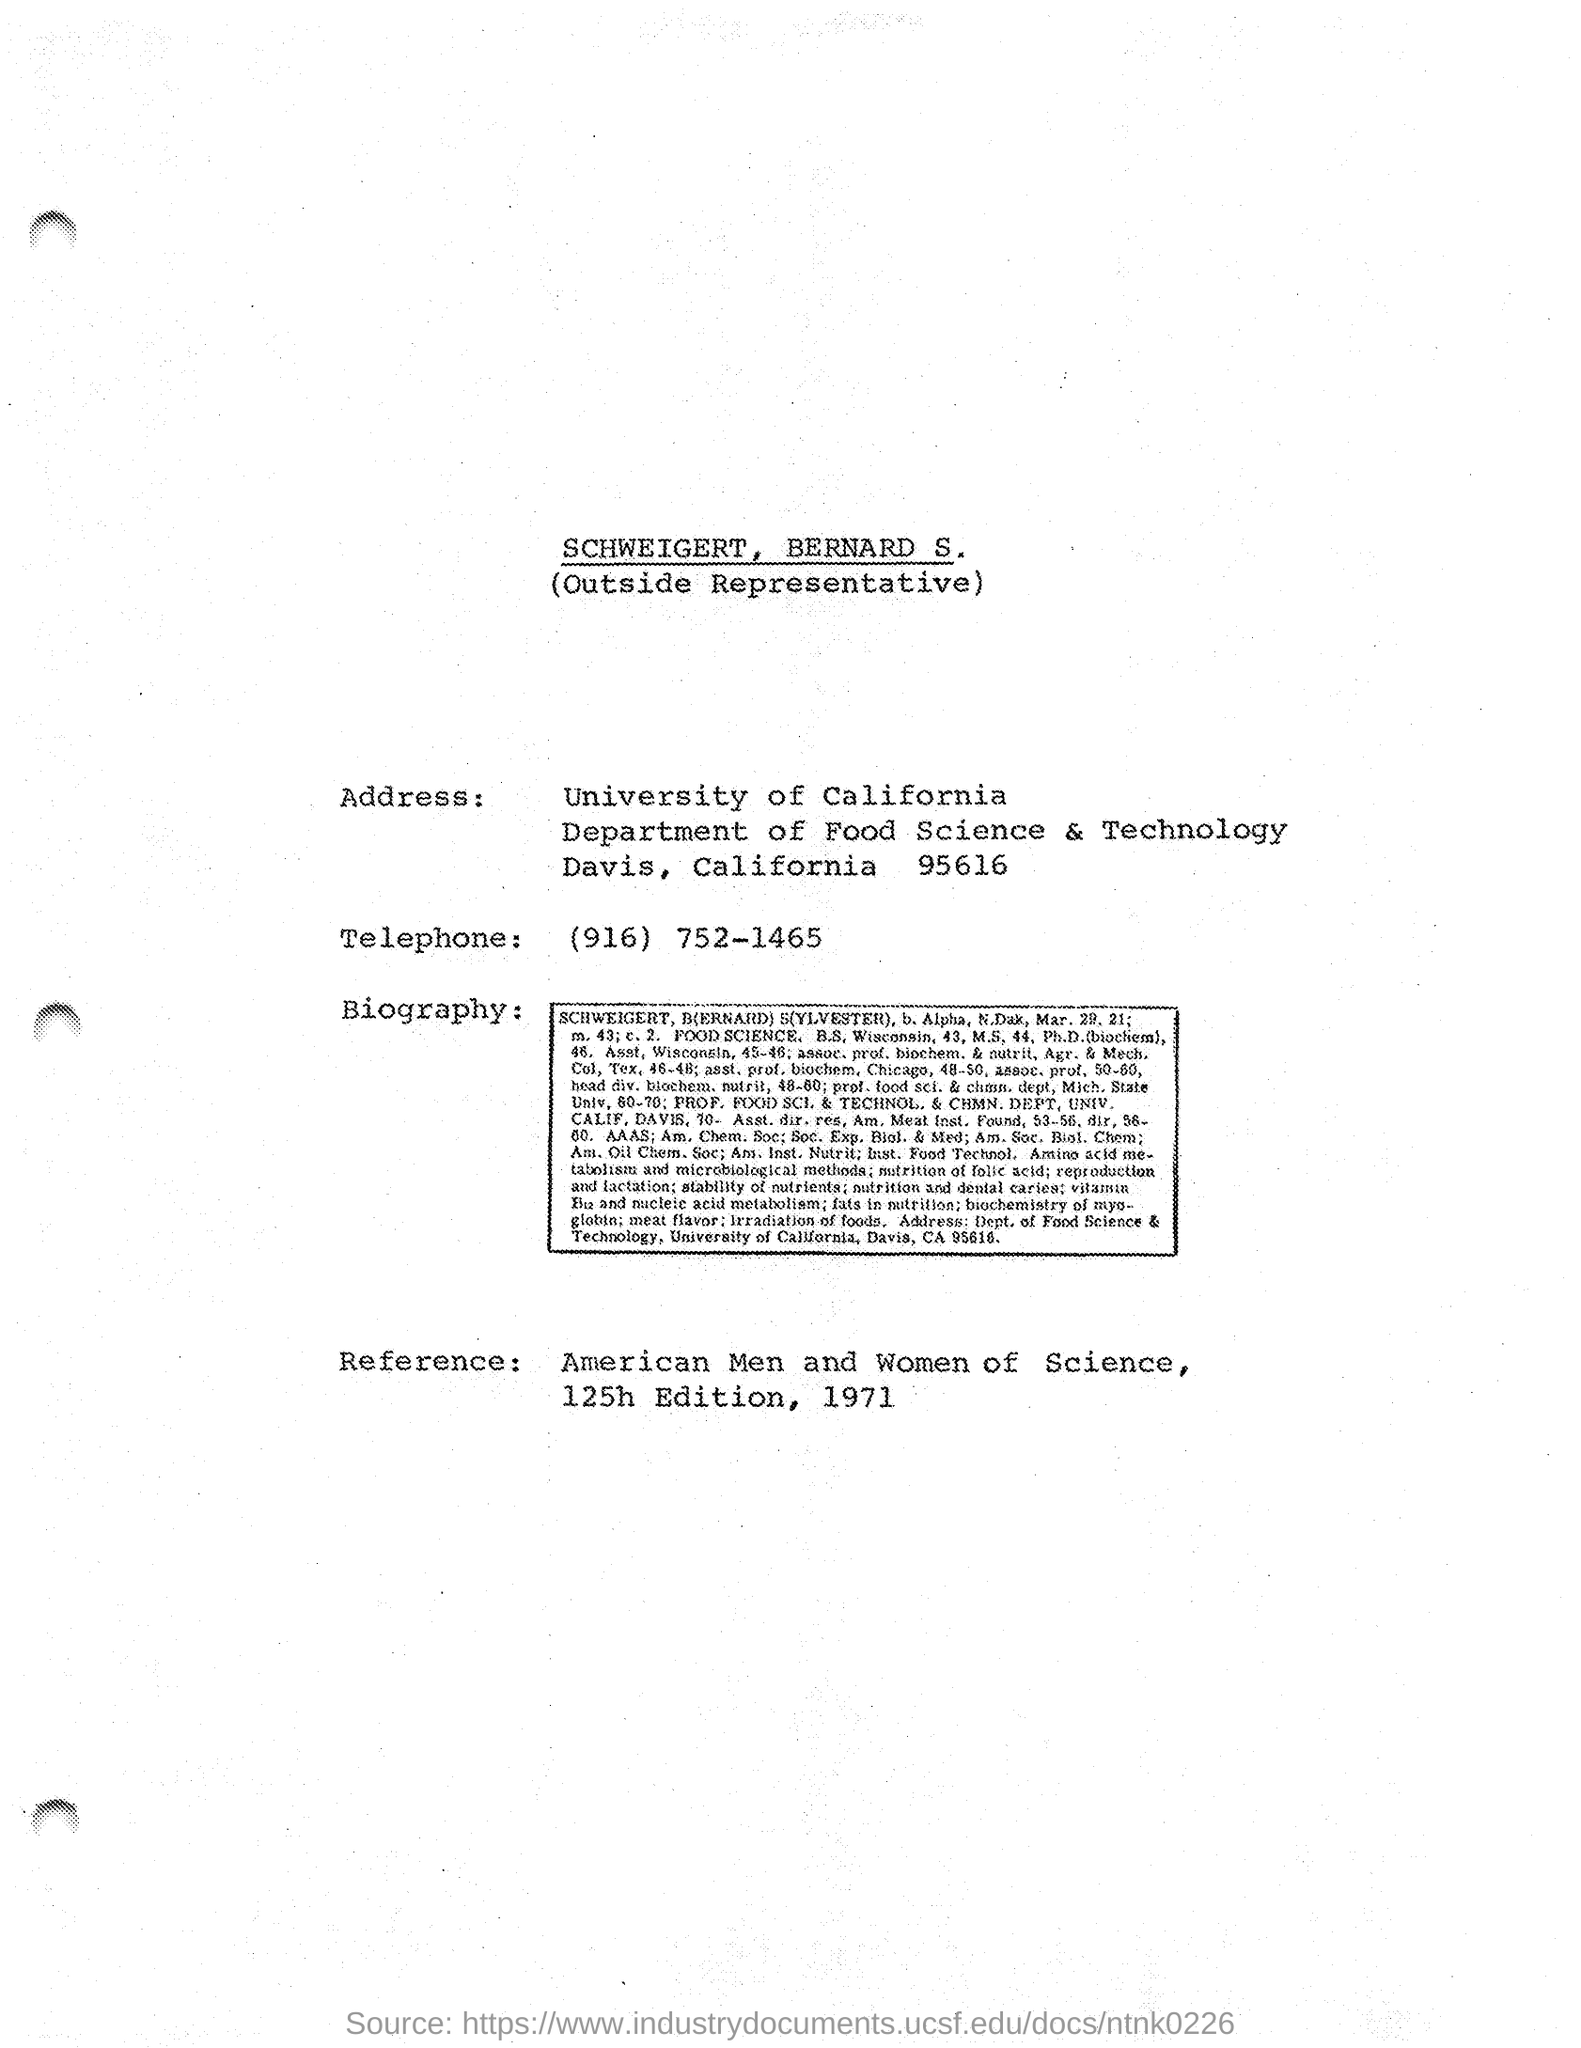Specify some key components in this picture. The telephone number of the University of California is (916) 752-1465. The department mentioned in the address is the Department of Food Science and Technology. 